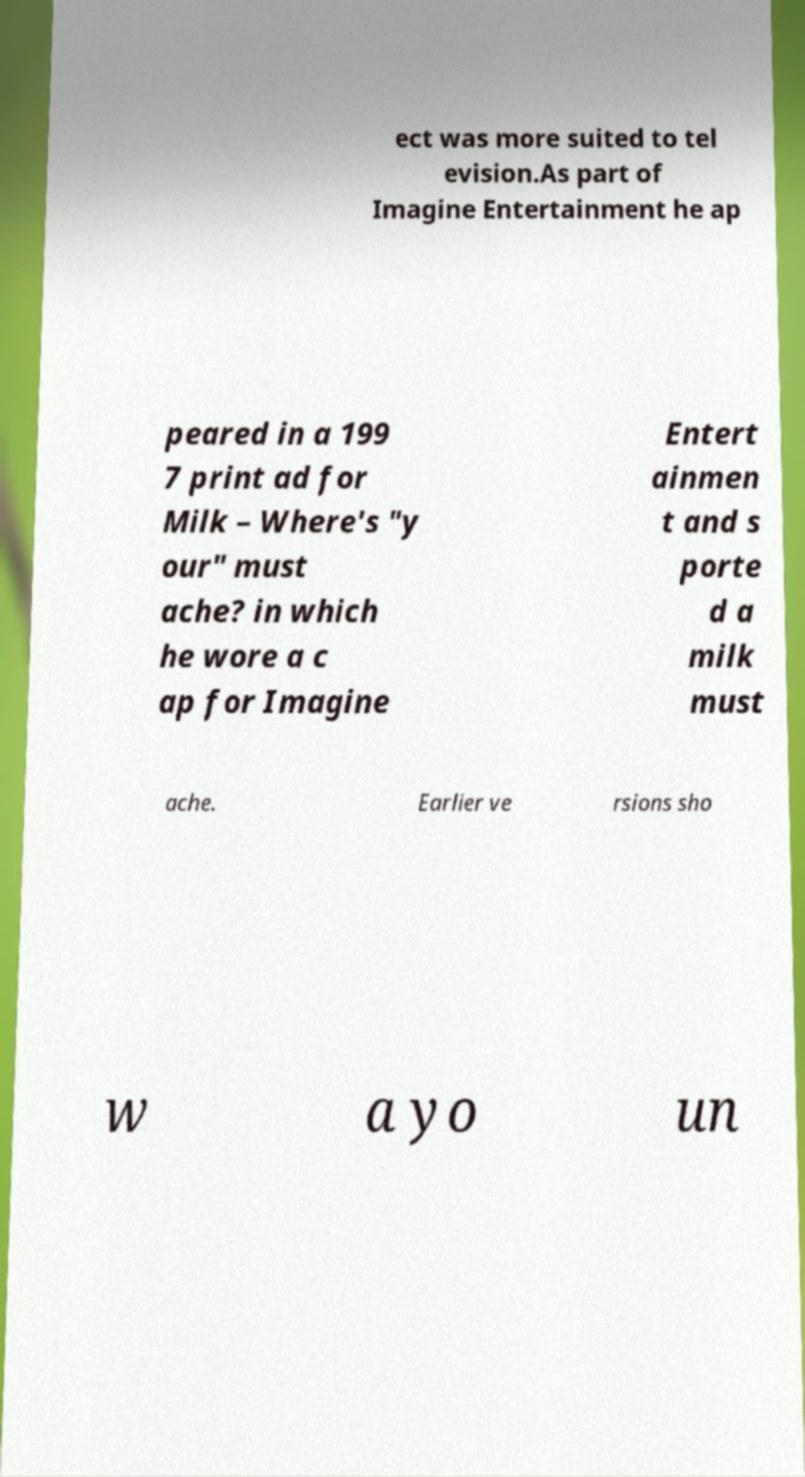Could you extract and type out the text from this image? ect was more suited to tel evision.As part of Imagine Entertainment he ap peared in a 199 7 print ad for Milk – Where's "y our" must ache? in which he wore a c ap for Imagine Entert ainmen t and s porte d a milk must ache. Earlier ve rsions sho w a yo un 